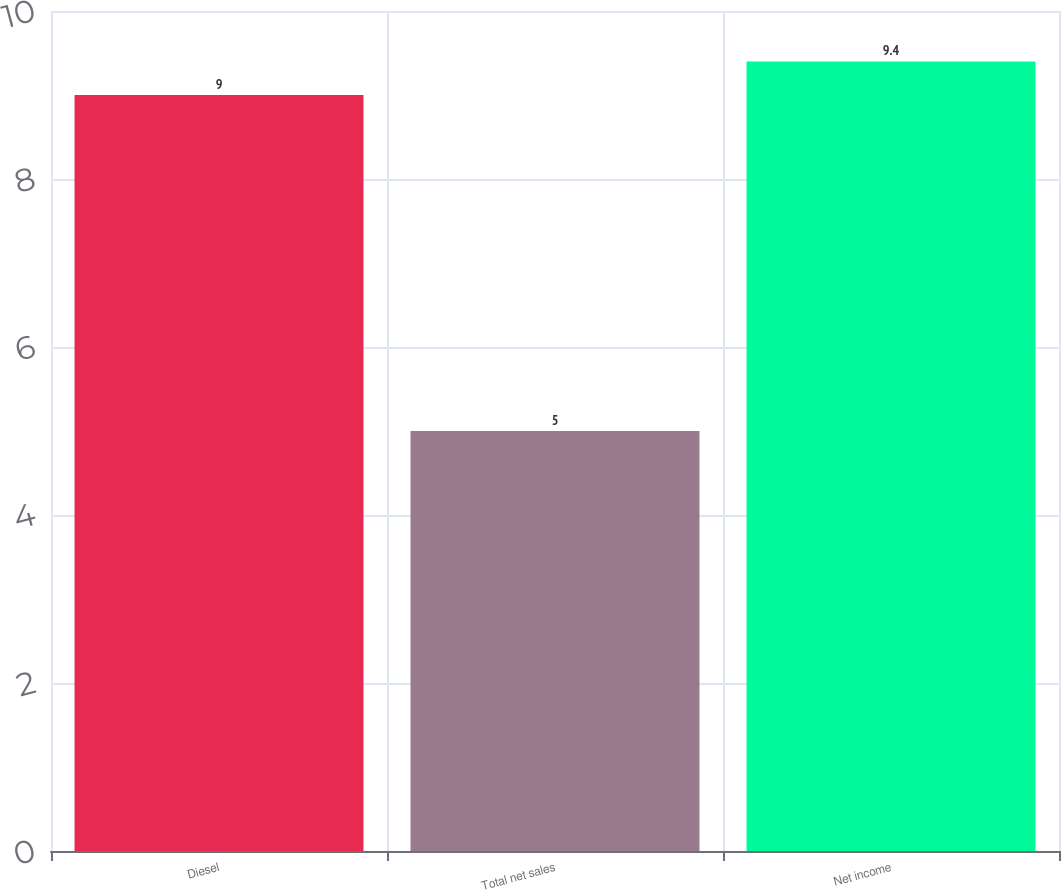<chart> <loc_0><loc_0><loc_500><loc_500><bar_chart><fcel>Diesel<fcel>Total net sales<fcel>Net income<nl><fcel>9<fcel>5<fcel>9.4<nl></chart> 